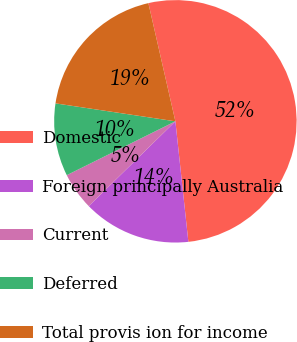Convert chart. <chart><loc_0><loc_0><loc_500><loc_500><pie_chart><fcel>Domestic<fcel>Foreign principally Australia<fcel>Current<fcel>Deferred<fcel>Total provis ion for income<nl><fcel>51.87%<fcel>14.38%<fcel>5.0%<fcel>9.69%<fcel>19.06%<nl></chart> 